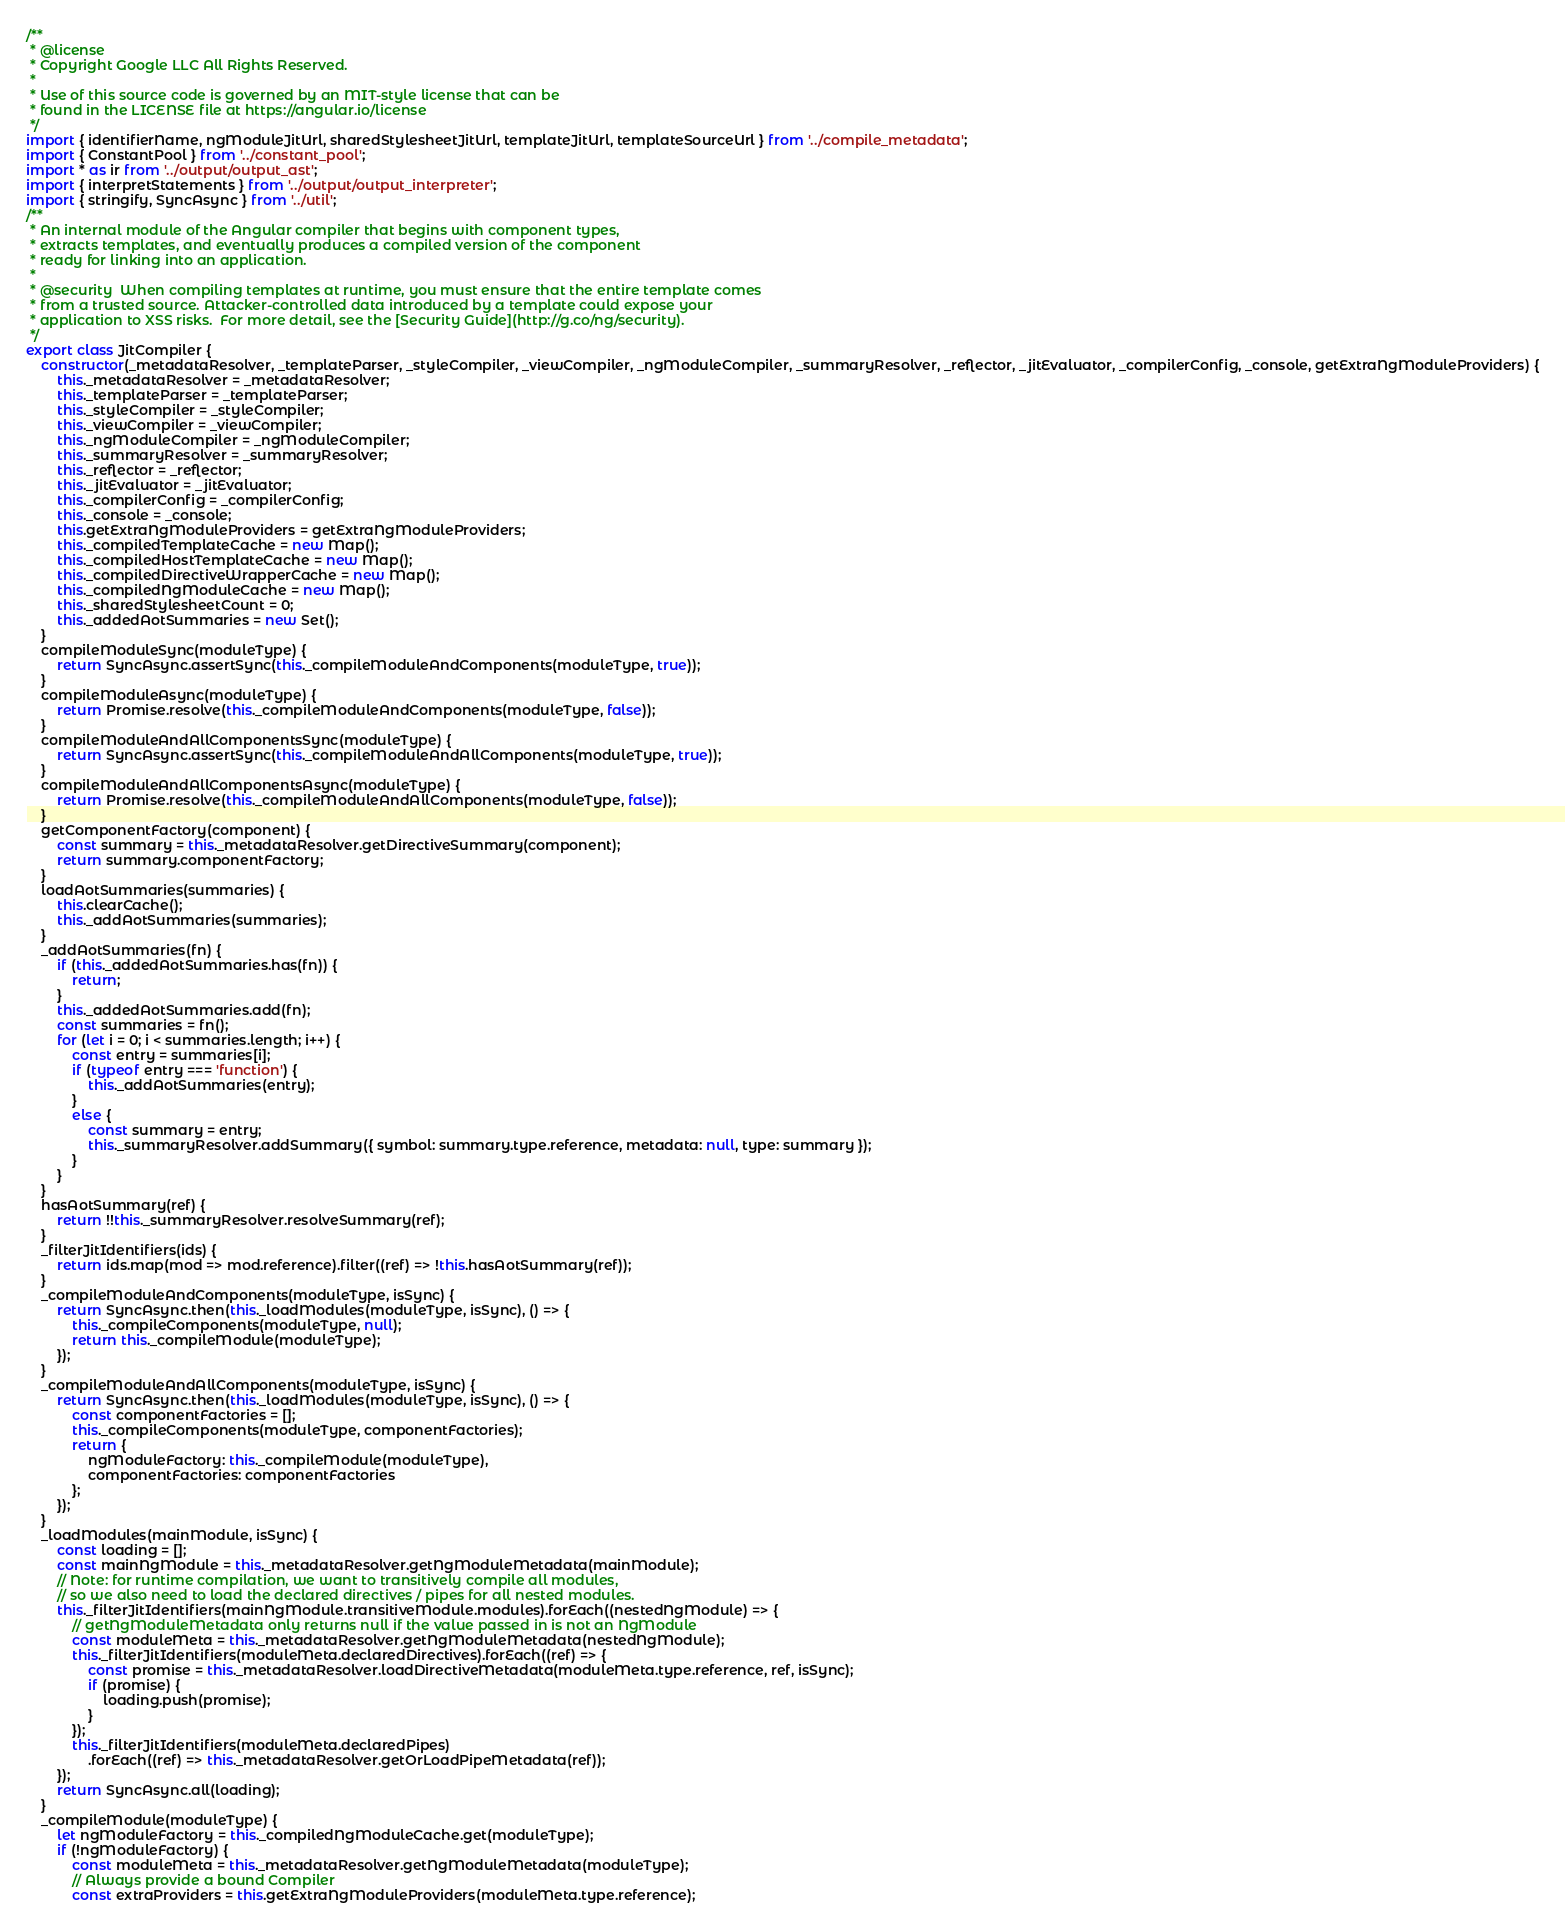Convert code to text. <code><loc_0><loc_0><loc_500><loc_500><_JavaScript_>/**
 * @license
 * Copyright Google LLC All Rights Reserved.
 *
 * Use of this source code is governed by an MIT-style license that can be
 * found in the LICENSE file at https://angular.io/license
 */
import { identifierName, ngModuleJitUrl, sharedStylesheetJitUrl, templateJitUrl, templateSourceUrl } from '../compile_metadata';
import { ConstantPool } from '../constant_pool';
import * as ir from '../output/output_ast';
import { interpretStatements } from '../output/output_interpreter';
import { stringify, SyncAsync } from '../util';
/**
 * An internal module of the Angular compiler that begins with component types,
 * extracts templates, and eventually produces a compiled version of the component
 * ready for linking into an application.
 *
 * @security  When compiling templates at runtime, you must ensure that the entire template comes
 * from a trusted source. Attacker-controlled data introduced by a template could expose your
 * application to XSS risks.  For more detail, see the [Security Guide](http://g.co/ng/security).
 */
export class JitCompiler {
    constructor(_metadataResolver, _templateParser, _styleCompiler, _viewCompiler, _ngModuleCompiler, _summaryResolver, _reflector, _jitEvaluator, _compilerConfig, _console, getExtraNgModuleProviders) {
        this._metadataResolver = _metadataResolver;
        this._templateParser = _templateParser;
        this._styleCompiler = _styleCompiler;
        this._viewCompiler = _viewCompiler;
        this._ngModuleCompiler = _ngModuleCompiler;
        this._summaryResolver = _summaryResolver;
        this._reflector = _reflector;
        this._jitEvaluator = _jitEvaluator;
        this._compilerConfig = _compilerConfig;
        this._console = _console;
        this.getExtraNgModuleProviders = getExtraNgModuleProviders;
        this._compiledTemplateCache = new Map();
        this._compiledHostTemplateCache = new Map();
        this._compiledDirectiveWrapperCache = new Map();
        this._compiledNgModuleCache = new Map();
        this._sharedStylesheetCount = 0;
        this._addedAotSummaries = new Set();
    }
    compileModuleSync(moduleType) {
        return SyncAsync.assertSync(this._compileModuleAndComponents(moduleType, true));
    }
    compileModuleAsync(moduleType) {
        return Promise.resolve(this._compileModuleAndComponents(moduleType, false));
    }
    compileModuleAndAllComponentsSync(moduleType) {
        return SyncAsync.assertSync(this._compileModuleAndAllComponents(moduleType, true));
    }
    compileModuleAndAllComponentsAsync(moduleType) {
        return Promise.resolve(this._compileModuleAndAllComponents(moduleType, false));
    }
    getComponentFactory(component) {
        const summary = this._metadataResolver.getDirectiveSummary(component);
        return summary.componentFactory;
    }
    loadAotSummaries(summaries) {
        this.clearCache();
        this._addAotSummaries(summaries);
    }
    _addAotSummaries(fn) {
        if (this._addedAotSummaries.has(fn)) {
            return;
        }
        this._addedAotSummaries.add(fn);
        const summaries = fn();
        for (let i = 0; i < summaries.length; i++) {
            const entry = summaries[i];
            if (typeof entry === 'function') {
                this._addAotSummaries(entry);
            }
            else {
                const summary = entry;
                this._summaryResolver.addSummary({ symbol: summary.type.reference, metadata: null, type: summary });
            }
        }
    }
    hasAotSummary(ref) {
        return !!this._summaryResolver.resolveSummary(ref);
    }
    _filterJitIdentifiers(ids) {
        return ids.map(mod => mod.reference).filter((ref) => !this.hasAotSummary(ref));
    }
    _compileModuleAndComponents(moduleType, isSync) {
        return SyncAsync.then(this._loadModules(moduleType, isSync), () => {
            this._compileComponents(moduleType, null);
            return this._compileModule(moduleType);
        });
    }
    _compileModuleAndAllComponents(moduleType, isSync) {
        return SyncAsync.then(this._loadModules(moduleType, isSync), () => {
            const componentFactories = [];
            this._compileComponents(moduleType, componentFactories);
            return {
                ngModuleFactory: this._compileModule(moduleType),
                componentFactories: componentFactories
            };
        });
    }
    _loadModules(mainModule, isSync) {
        const loading = [];
        const mainNgModule = this._metadataResolver.getNgModuleMetadata(mainModule);
        // Note: for runtime compilation, we want to transitively compile all modules,
        // so we also need to load the declared directives / pipes for all nested modules.
        this._filterJitIdentifiers(mainNgModule.transitiveModule.modules).forEach((nestedNgModule) => {
            // getNgModuleMetadata only returns null if the value passed in is not an NgModule
            const moduleMeta = this._metadataResolver.getNgModuleMetadata(nestedNgModule);
            this._filterJitIdentifiers(moduleMeta.declaredDirectives).forEach((ref) => {
                const promise = this._metadataResolver.loadDirectiveMetadata(moduleMeta.type.reference, ref, isSync);
                if (promise) {
                    loading.push(promise);
                }
            });
            this._filterJitIdentifiers(moduleMeta.declaredPipes)
                .forEach((ref) => this._metadataResolver.getOrLoadPipeMetadata(ref));
        });
        return SyncAsync.all(loading);
    }
    _compileModule(moduleType) {
        let ngModuleFactory = this._compiledNgModuleCache.get(moduleType);
        if (!ngModuleFactory) {
            const moduleMeta = this._metadataResolver.getNgModuleMetadata(moduleType);
            // Always provide a bound Compiler
            const extraProviders = this.getExtraNgModuleProviders(moduleMeta.type.reference);</code> 